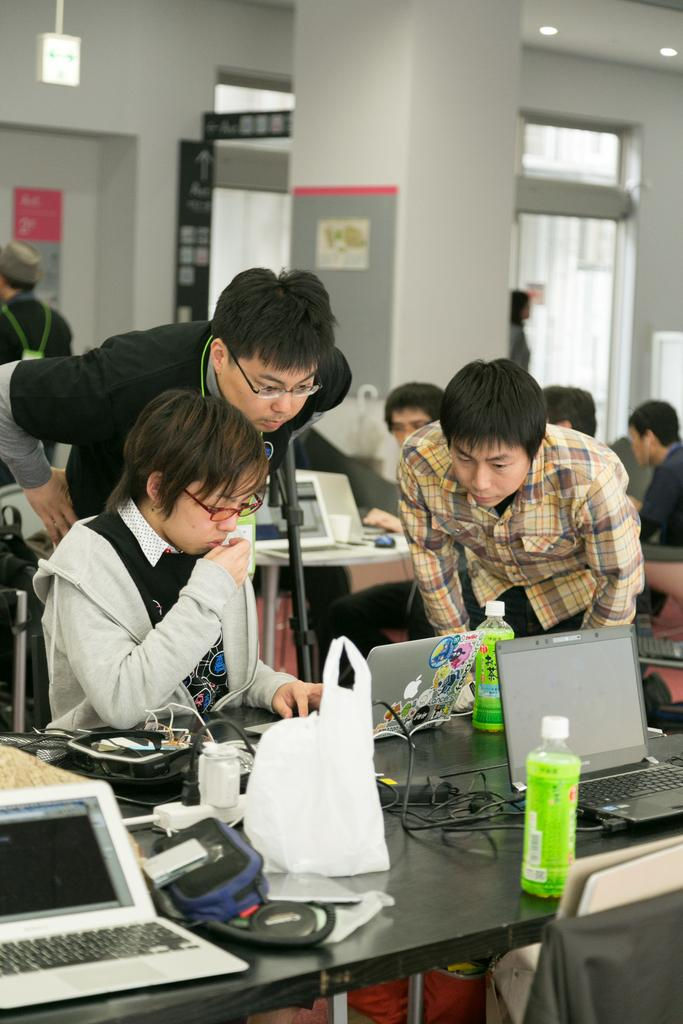What is the person in the image doing? The person in the image is sitting and working on a laptop. Can you describe the person standing behind the one working on the laptop? The man standing behind is looking at the person working on the laptop and is wearing a black color t-shirt. How many people are standing in the image? There are two people standing in the image, one behind the person working on the laptop and another on the right side of the image. What degree does the person sitting on the left side of the image have? There is no information about the person's degree in the image, as it only shows them working on a laptop. Can you see any wings on the people in the image? There are no wings visible on the people in the image. 